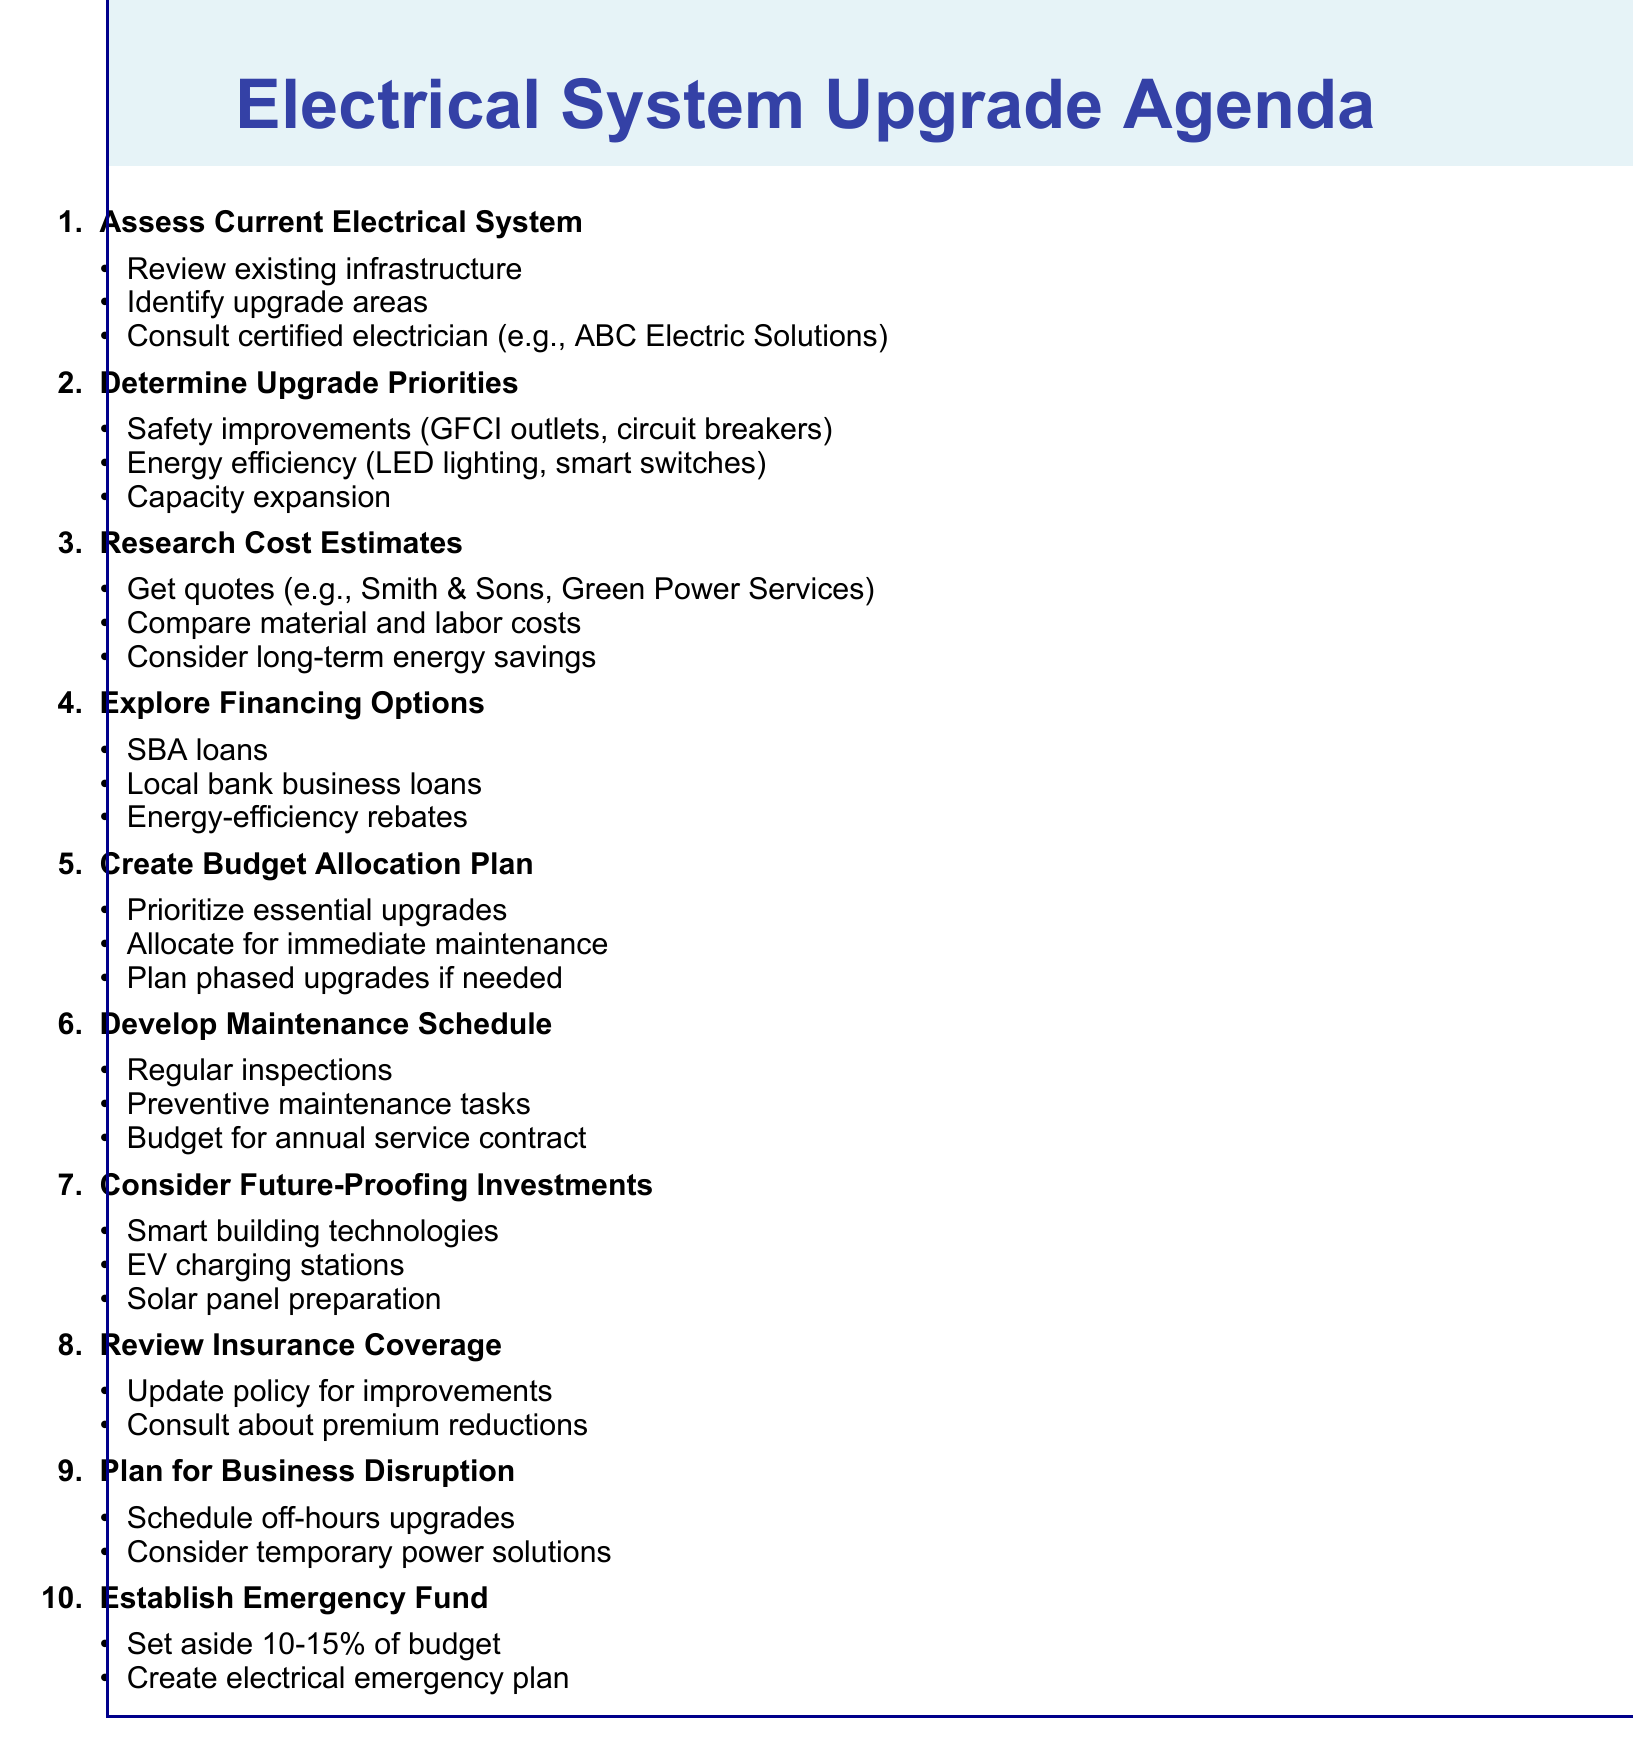what is the first agenda item? The first agenda item is listed at the beginning of the document and is titled "Assess Current Electrical System."
Answer: Assess Current Electrical System which company is suggested for professional assessment? The document mentions a specific company for professional assessment in the first agenda item, which is "ABC Electric Solutions."
Answer: ABC Electric Solutions how much should be set aside for the emergency fund? The emergency fund allocation is specified in the last agenda item and is set at 10-15% of the upgrade budget.
Answer: 10-15% what are two examples of energy efficiency upgrades? The second agenda item lists examples of energy efficiency upgrades, including "LED lighting" and "smart switches."
Answer: LED lighting, smart switches which financial option is mentioned for small businesses? The document lists financing options in the fourth agenda item including "Small Business Administration (SBA) loans."
Answer: Small Business Administration (SBA) loans what should the maintenance schedule include? The sixth agenda item outlines that the maintenance schedule should include "Regular inspections" as part of its details.
Answer: Regular inspections what should be prioritized in the budget allocation plan? The fifth agenda item states that "essential upgrades" should be prioritized in the budget allocation plan.
Answer: Essential upgrades what is recommended to minimize business disruption during upgrades? The ninth agenda item suggests "Schedule upgrades during off-hours or slower business periods" to minimize disruption.
Answer: Schedule upgrades during off-hours or slower business periods 